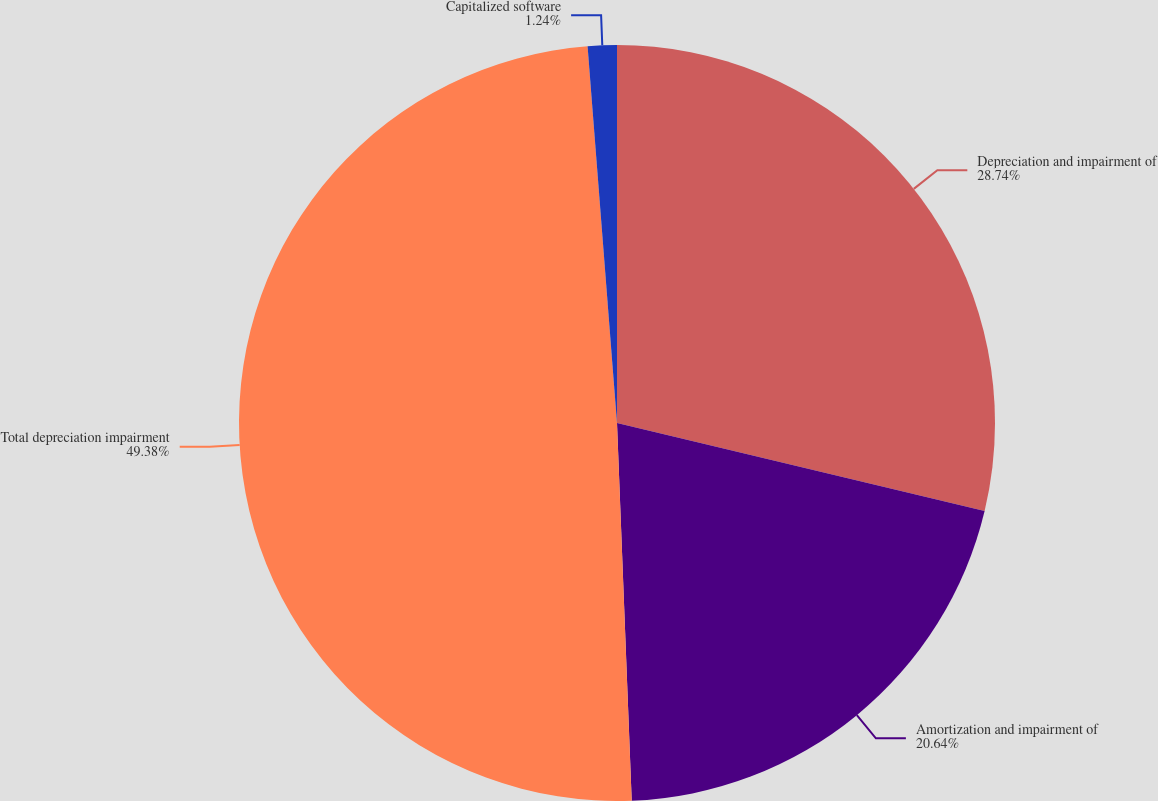Convert chart to OTSL. <chart><loc_0><loc_0><loc_500><loc_500><pie_chart><fcel>Depreciation and impairment of<fcel>Amortization and impairment of<fcel>Total depreciation impairment<fcel>Capitalized software<nl><fcel>28.74%<fcel>20.64%<fcel>49.38%<fcel>1.24%<nl></chart> 